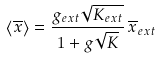<formula> <loc_0><loc_0><loc_500><loc_500>\left < \overline { x } \right > = \frac { g _ { e x t } \sqrt { K _ { e x t } } } { 1 + g \sqrt { K } } \, \overline { x } _ { e x t }</formula> 